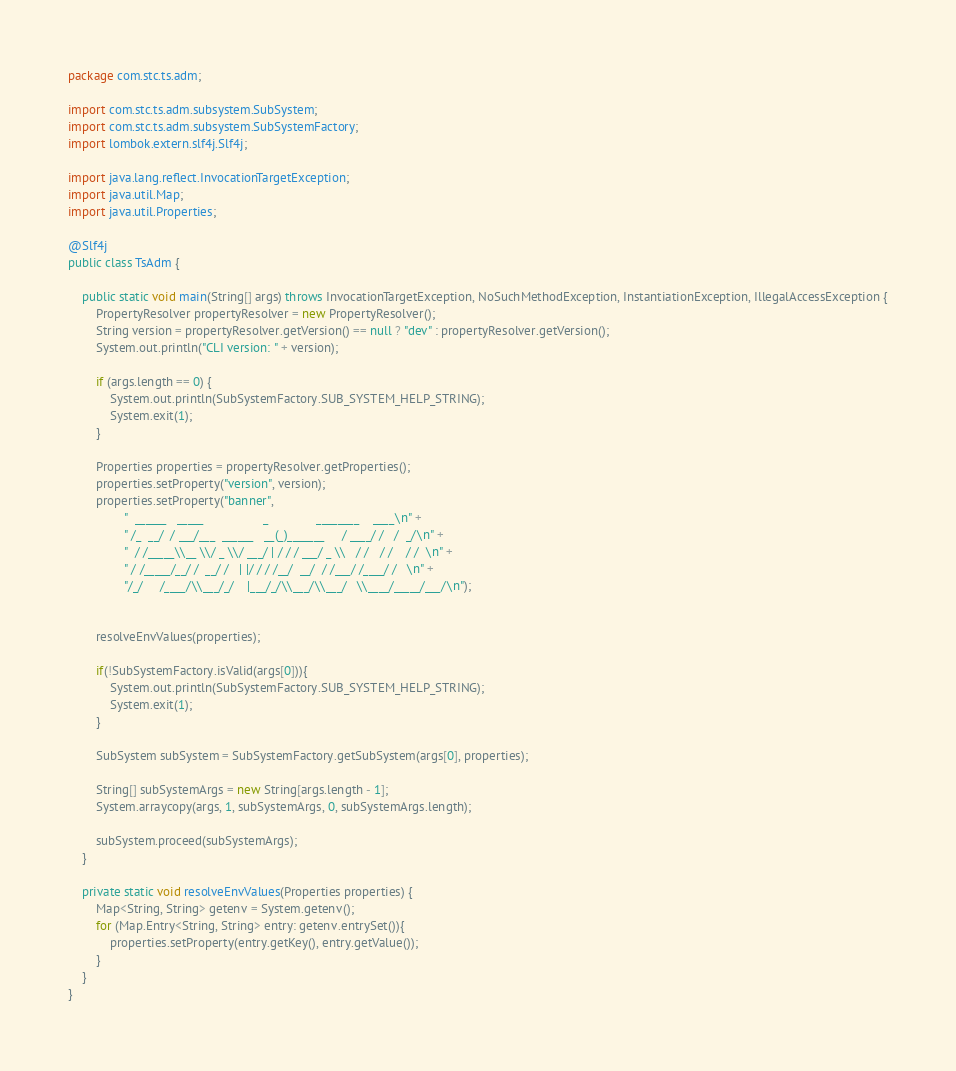Convert code to text. <code><loc_0><loc_0><loc_500><loc_500><_Java_>package com.stc.ts.adm;

import com.stc.ts.adm.subsystem.SubSystem;
import com.stc.ts.adm.subsystem.SubSystemFactory;
import lombok.extern.slf4j.Slf4j;

import java.lang.reflect.InvocationTargetException;
import java.util.Map;
import java.util.Properties;

@Slf4j
public class TsAdm {

    public static void main(String[] args) throws InvocationTargetException, NoSuchMethodException, InstantiationException, IllegalAccessException {
        PropertyResolver propertyResolver = new PropertyResolver();
        String version = propertyResolver.getVersion() == null ? "dev" : propertyResolver.getVersion();
        System.out.println("CLI version: " + version);

        if (args.length == 0) {
            System.out.println(SubSystemFactory.SUB_SYSTEM_HELP_STRING);
            System.exit(1);
        }

        Properties properties = propertyResolver.getProperties();
        properties.setProperty("version", version);
        properties.setProperty("banner",
                "  ______   _____                 _              ________    ____\n" +
                " /_  __/  / ___/___  ______   __(_)_______     / ____/ /   /  _/\n" +
                "  / /_____\\__ \\/ _ \\/ ___/ | / / / ___/ _ \\   / /   / /    / /  \n" +
                " / /_____/__/ /  __/ /   | |/ / / /__/  __/  / /___/ /____/ /   \n" +
                "/_/     /____/\\___/_/    |___/_/\\___/\\___/   \\____/_____/___/\n");


        resolveEnvValues(properties);

        if(!SubSystemFactory.isValid(args[0])){
            System.out.println(SubSystemFactory.SUB_SYSTEM_HELP_STRING);
            System.exit(1);
        }

        SubSystem subSystem = SubSystemFactory.getSubSystem(args[0], properties);

        String[] subSystemArgs = new String[args.length - 1];
        System.arraycopy(args, 1, subSystemArgs, 0, subSystemArgs.length);

        subSystem.proceed(subSystemArgs);
    }

    private static void resolveEnvValues(Properties properties) {
        Map<String, String> getenv = System.getenv();
        for (Map.Entry<String, String> entry: getenv.entrySet()){
            properties.setProperty(entry.getKey(), entry.getValue());
        }
    }
}
</code> 